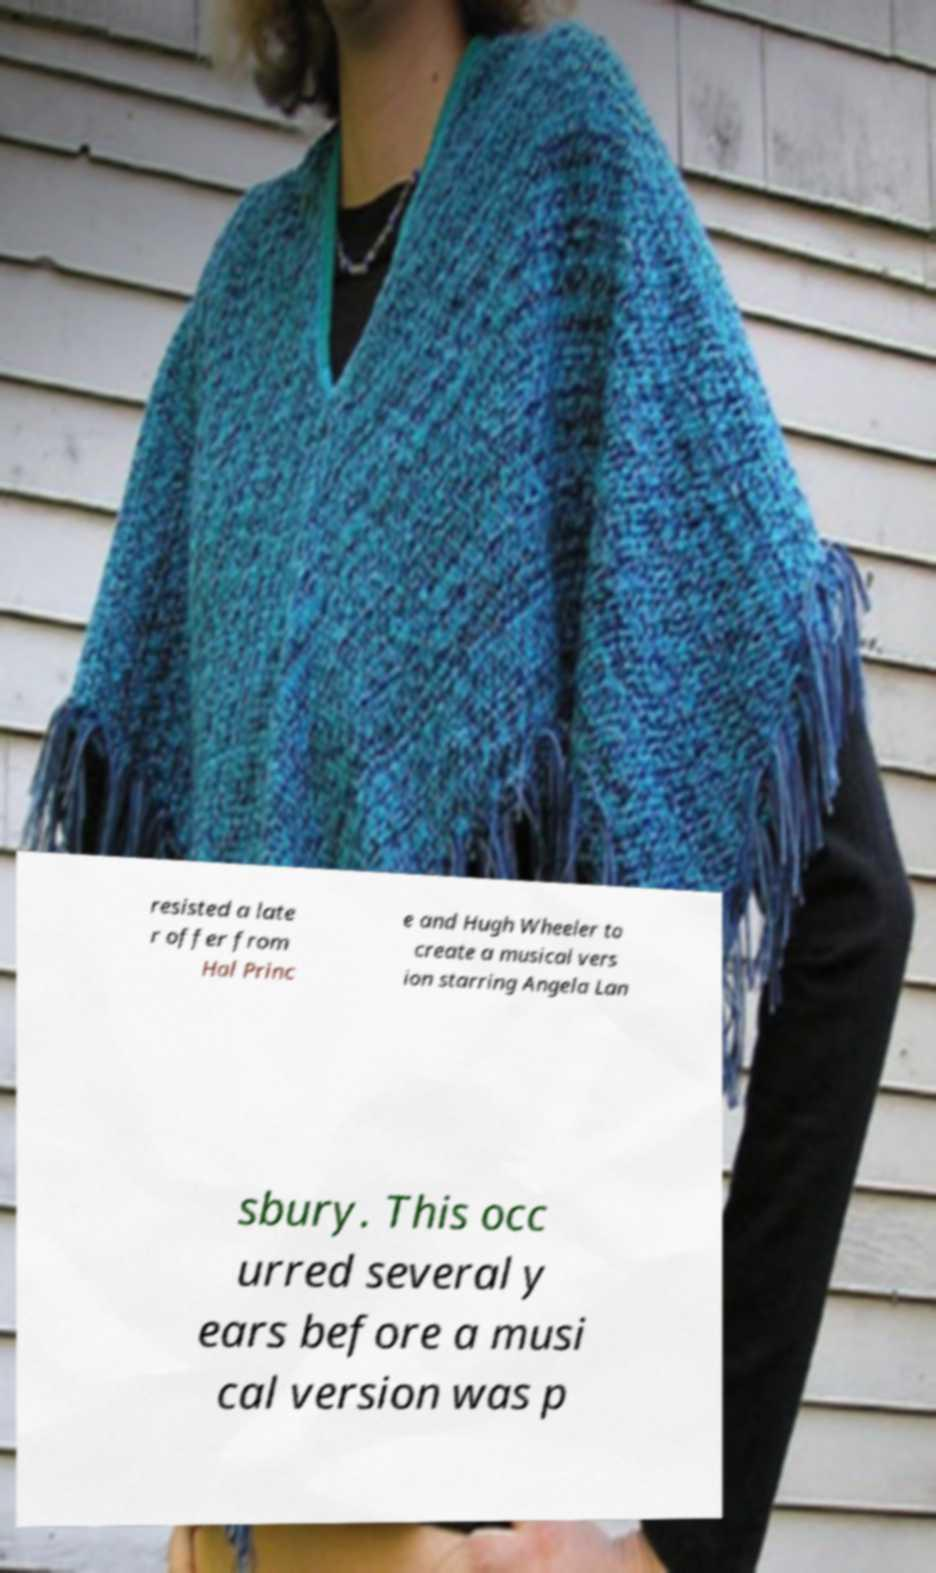Please read and relay the text visible in this image. What does it say? resisted a late r offer from Hal Princ e and Hugh Wheeler to create a musical vers ion starring Angela Lan sbury. This occ urred several y ears before a musi cal version was p 